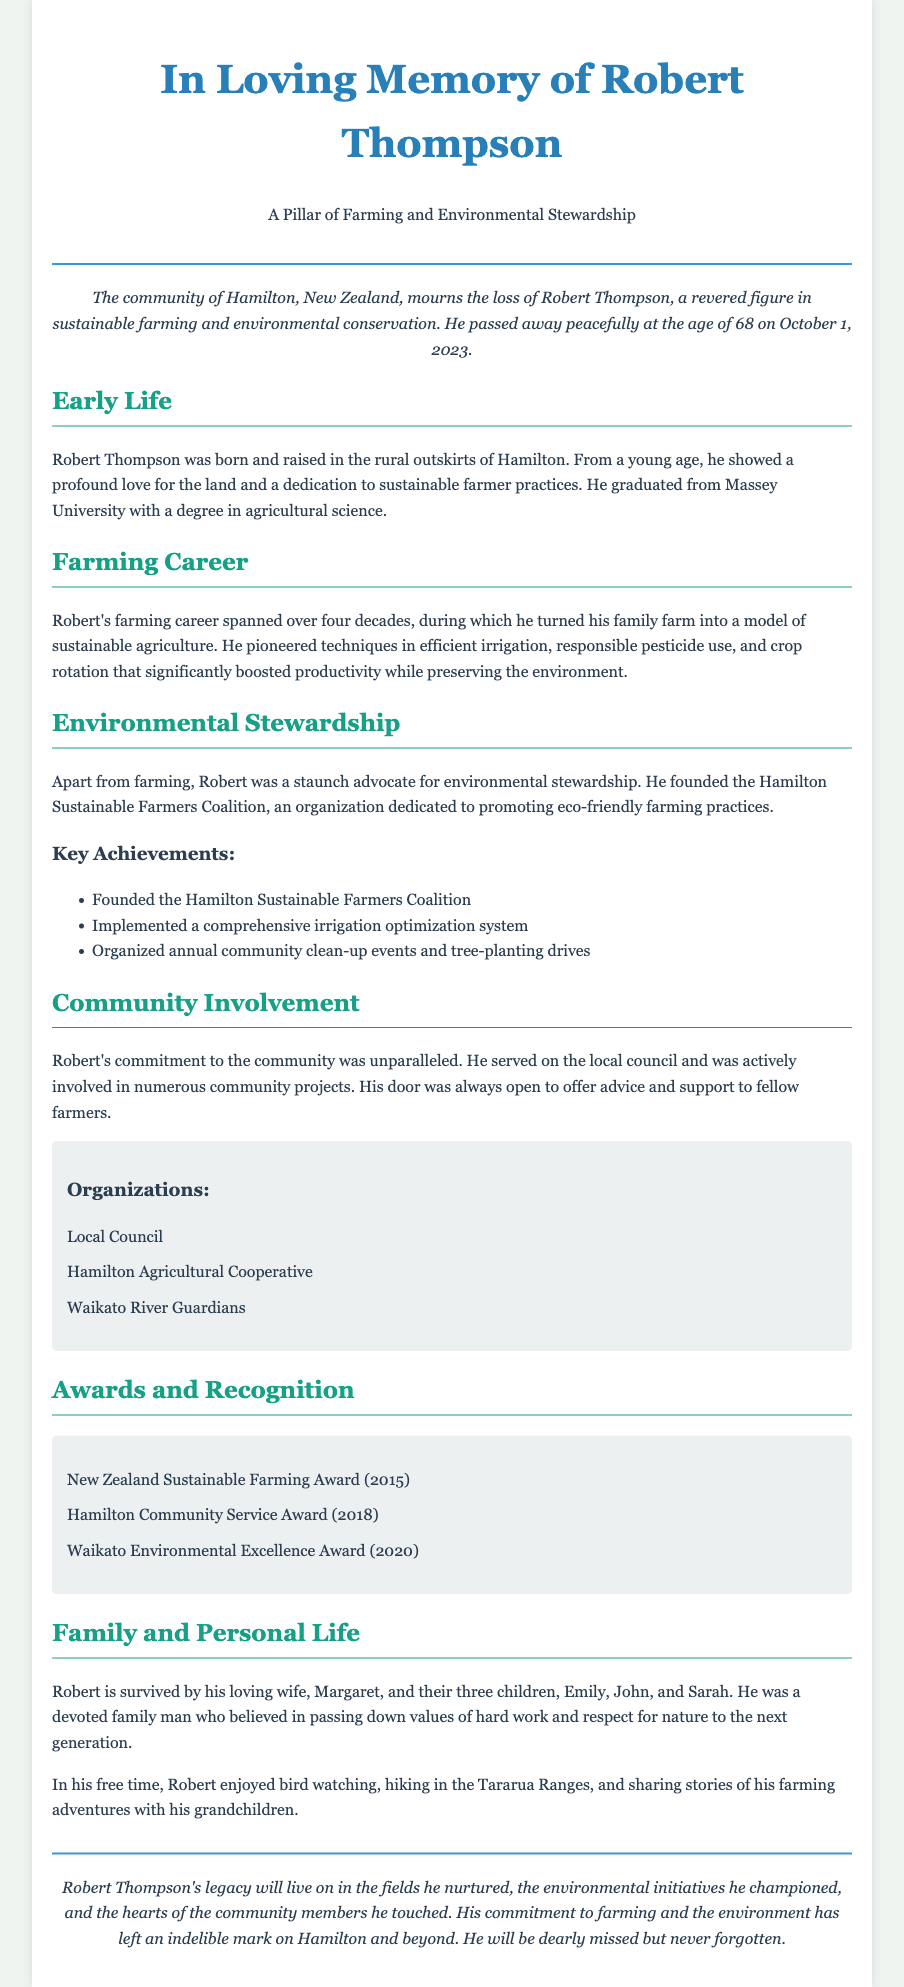what was Robert Thompson's age at the time of his passing? The document states he passed away at the age of 68.
Answer: 68 when did Robert Thompson pass away? The obituary mentions he passed away on October 1, 2023.
Answer: October 1, 2023 what university did Robert graduate from? The document specifies that he graduated from Massey University.
Answer: Massey University what organization did Robert found? The obituary highlights that he founded the Hamilton Sustainable Farmers Coalition.
Answer: Hamilton Sustainable Farmers Coalition how many children did Robert have? The document indicates he had three children: Emily, John, and Sarah.
Answer: three which award did Robert receive in 2020? The document lists that he received the Waikato Environmental Excellence Award in 2020.
Answer: Waikato Environmental Excellence Award how long was Robert's farming career? The obituary states that his farming career spanned over four decades.
Answer: over four decades what was Robert's primary focus in his farming practices? The document notes he focused on sustainable agriculture.
Answer: sustainable agriculture what was one of Robert's hobbies mentioned in the document? The obituary states that he enjoyed bird watching.
Answer: bird watching 